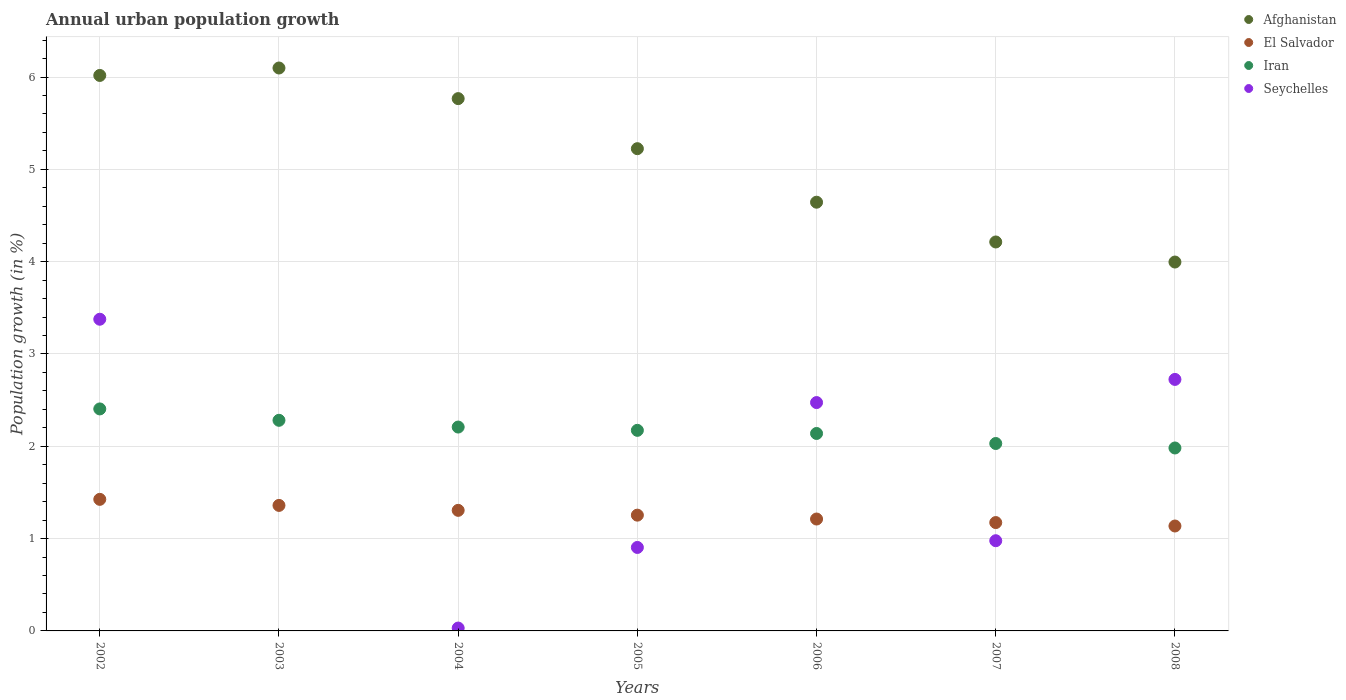Is the number of dotlines equal to the number of legend labels?
Give a very brief answer. No. What is the percentage of urban population growth in El Salvador in 2008?
Your response must be concise. 1.14. Across all years, what is the maximum percentage of urban population growth in Afghanistan?
Your response must be concise. 6.1. Across all years, what is the minimum percentage of urban population growth in Afghanistan?
Give a very brief answer. 4. In which year was the percentage of urban population growth in Iran maximum?
Offer a terse response. 2002. What is the total percentage of urban population growth in Afghanistan in the graph?
Provide a short and direct response. 35.96. What is the difference between the percentage of urban population growth in Iran in 2002 and that in 2006?
Offer a terse response. 0.27. What is the difference between the percentage of urban population growth in Seychelles in 2004 and the percentage of urban population growth in Iran in 2007?
Offer a terse response. -2. What is the average percentage of urban population growth in El Salvador per year?
Keep it short and to the point. 1.27. In the year 2008, what is the difference between the percentage of urban population growth in Afghanistan and percentage of urban population growth in Iran?
Your answer should be compact. 2.01. What is the ratio of the percentage of urban population growth in Iran in 2005 to that in 2006?
Provide a succinct answer. 1.02. Is the percentage of urban population growth in Seychelles in 2004 less than that in 2005?
Keep it short and to the point. Yes. Is the difference between the percentage of urban population growth in Afghanistan in 2006 and 2008 greater than the difference between the percentage of urban population growth in Iran in 2006 and 2008?
Keep it short and to the point. Yes. What is the difference between the highest and the second highest percentage of urban population growth in El Salvador?
Your answer should be very brief. 0.07. What is the difference between the highest and the lowest percentage of urban population growth in Afghanistan?
Keep it short and to the point. 2.1. In how many years, is the percentage of urban population growth in Afghanistan greater than the average percentage of urban population growth in Afghanistan taken over all years?
Give a very brief answer. 4. Is it the case that in every year, the sum of the percentage of urban population growth in El Salvador and percentage of urban population growth in Iran  is greater than the sum of percentage of urban population growth in Afghanistan and percentage of urban population growth in Seychelles?
Give a very brief answer. No. Is the percentage of urban population growth in Iran strictly greater than the percentage of urban population growth in Seychelles over the years?
Your response must be concise. No. Is the percentage of urban population growth in Iran strictly less than the percentage of urban population growth in Seychelles over the years?
Ensure brevity in your answer.  No. How many years are there in the graph?
Provide a succinct answer. 7. What is the difference between two consecutive major ticks on the Y-axis?
Keep it short and to the point. 1. Are the values on the major ticks of Y-axis written in scientific E-notation?
Offer a terse response. No. Does the graph contain any zero values?
Keep it short and to the point. Yes. Does the graph contain grids?
Provide a short and direct response. Yes. How are the legend labels stacked?
Your answer should be very brief. Vertical. What is the title of the graph?
Your response must be concise. Annual urban population growth. Does "Cote d'Ivoire" appear as one of the legend labels in the graph?
Keep it short and to the point. No. What is the label or title of the Y-axis?
Offer a terse response. Population growth (in %). What is the Population growth (in %) in Afghanistan in 2002?
Ensure brevity in your answer.  6.02. What is the Population growth (in %) in El Salvador in 2002?
Keep it short and to the point. 1.43. What is the Population growth (in %) in Iran in 2002?
Give a very brief answer. 2.4. What is the Population growth (in %) of Seychelles in 2002?
Your answer should be compact. 3.38. What is the Population growth (in %) in Afghanistan in 2003?
Provide a succinct answer. 6.1. What is the Population growth (in %) in El Salvador in 2003?
Give a very brief answer. 1.36. What is the Population growth (in %) in Iran in 2003?
Your answer should be compact. 2.28. What is the Population growth (in %) in Afghanistan in 2004?
Offer a terse response. 5.77. What is the Population growth (in %) of El Salvador in 2004?
Ensure brevity in your answer.  1.31. What is the Population growth (in %) of Iran in 2004?
Provide a short and direct response. 2.21. What is the Population growth (in %) of Seychelles in 2004?
Provide a succinct answer. 0.03. What is the Population growth (in %) in Afghanistan in 2005?
Offer a terse response. 5.22. What is the Population growth (in %) of El Salvador in 2005?
Provide a short and direct response. 1.25. What is the Population growth (in %) of Iran in 2005?
Keep it short and to the point. 2.17. What is the Population growth (in %) of Seychelles in 2005?
Provide a succinct answer. 0.9. What is the Population growth (in %) of Afghanistan in 2006?
Give a very brief answer. 4.64. What is the Population growth (in %) in El Salvador in 2006?
Provide a short and direct response. 1.21. What is the Population growth (in %) of Iran in 2006?
Keep it short and to the point. 2.14. What is the Population growth (in %) in Seychelles in 2006?
Ensure brevity in your answer.  2.47. What is the Population growth (in %) in Afghanistan in 2007?
Give a very brief answer. 4.21. What is the Population growth (in %) in El Salvador in 2007?
Offer a very short reply. 1.17. What is the Population growth (in %) of Iran in 2007?
Provide a succinct answer. 2.03. What is the Population growth (in %) in Seychelles in 2007?
Keep it short and to the point. 0.98. What is the Population growth (in %) of Afghanistan in 2008?
Make the answer very short. 4. What is the Population growth (in %) in El Salvador in 2008?
Your response must be concise. 1.14. What is the Population growth (in %) of Iran in 2008?
Your answer should be compact. 1.98. What is the Population growth (in %) in Seychelles in 2008?
Your answer should be compact. 2.72. Across all years, what is the maximum Population growth (in %) in Afghanistan?
Give a very brief answer. 6.1. Across all years, what is the maximum Population growth (in %) in El Salvador?
Your response must be concise. 1.43. Across all years, what is the maximum Population growth (in %) of Iran?
Offer a terse response. 2.4. Across all years, what is the maximum Population growth (in %) of Seychelles?
Make the answer very short. 3.38. Across all years, what is the minimum Population growth (in %) of Afghanistan?
Your answer should be very brief. 4. Across all years, what is the minimum Population growth (in %) in El Salvador?
Give a very brief answer. 1.14. Across all years, what is the minimum Population growth (in %) in Iran?
Keep it short and to the point. 1.98. Across all years, what is the minimum Population growth (in %) of Seychelles?
Your answer should be compact. 0. What is the total Population growth (in %) of Afghanistan in the graph?
Offer a very short reply. 35.96. What is the total Population growth (in %) of El Salvador in the graph?
Provide a succinct answer. 8.87. What is the total Population growth (in %) of Iran in the graph?
Provide a succinct answer. 15.22. What is the total Population growth (in %) of Seychelles in the graph?
Offer a terse response. 10.49. What is the difference between the Population growth (in %) in Afghanistan in 2002 and that in 2003?
Provide a short and direct response. -0.08. What is the difference between the Population growth (in %) in El Salvador in 2002 and that in 2003?
Your answer should be very brief. 0.07. What is the difference between the Population growth (in %) in Iran in 2002 and that in 2003?
Provide a short and direct response. 0.12. What is the difference between the Population growth (in %) of Afghanistan in 2002 and that in 2004?
Keep it short and to the point. 0.25. What is the difference between the Population growth (in %) in El Salvador in 2002 and that in 2004?
Make the answer very short. 0.12. What is the difference between the Population growth (in %) of Iran in 2002 and that in 2004?
Your answer should be very brief. 0.2. What is the difference between the Population growth (in %) in Seychelles in 2002 and that in 2004?
Offer a very short reply. 3.35. What is the difference between the Population growth (in %) in Afghanistan in 2002 and that in 2005?
Your response must be concise. 0.79. What is the difference between the Population growth (in %) in El Salvador in 2002 and that in 2005?
Make the answer very short. 0.17. What is the difference between the Population growth (in %) in Iran in 2002 and that in 2005?
Keep it short and to the point. 0.23. What is the difference between the Population growth (in %) in Seychelles in 2002 and that in 2005?
Provide a succinct answer. 2.47. What is the difference between the Population growth (in %) of Afghanistan in 2002 and that in 2006?
Offer a terse response. 1.37. What is the difference between the Population growth (in %) of El Salvador in 2002 and that in 2006?
Your answer should be very brief. 0.21. What is the difference between the Population growth (in %) of Iran in 2002 and that in 2006?
Keep it short and to the point. 0.27. What is the difference between the Population growth (in %) of Seychelles in 2002 and that in 2006?
Ensure brevity in your answer.  0.9. What is the difference between the Population growth (in %) of Afghanistan in 2002 and that in 2007?
Provide a short and direct response. 1.8. What is the difference between the Population growth (in %) in El Salvador in 2002 and that in 2007?
Offer a very short reply. 0.25. What is the difference between the Population growth (in %) in Iran in 2002 and that in 2007?
Keep it short and to the point. 0.37. What is the difference between the Population growth (in %) of Seychelles in 2002 and that in 2007?
Your answer should be very brief. 2.4. What is the difference between the Population growth (in %) in Afghanistan in 2002 and that in 2008?
Your response must be concise. 2.02. What is the difference between the Population growth (in %) of El Salvador in 2002 and that in 2008?
Give a very brief answer. 0.29. What is the difference between the Population growth (in %) in Iran in 2002 and that in 2008?
Make the answer very short. 0.42. What is the difference between the Population growth (in %) in Seychelles in 2002 and that in 2008?
Provide a succinct answer. 0.65. What is the difference between the Population growth (in %) of Afghanistan in 2003 and that in 2004?
Give a very brief answer. 0.33. What is the difference between the Population growth (in %) of El Salvador in 2003 and that in 2004?
Ensure brevity in your answer.  0.05. What is the difference between the Population growth (in %) in Iran in 2003 and that in 2004?
Your answer should be compact. 0.07. What is the difference between the Population growth (in %) of Afghanistan in 2003 and that in 2005?
Your answer should be compact. 0.87. What is the difference between the Population growth (in %) of El Salvador in 2003 and that in 2005?
Give a very brief answer. 0.11. What is the difference between the Population growth (in %) in Iran in 2003 and that in 2005?
Provide a succinct answer. 0.11. What is the difference between the Population growth (in %) in Afghanistan in 2003 and that in 2006?
Provide a short and direct response. 1.45. What is the difference between the Population growth (in %) in El Salvador in 2003 and that in 2006?
Your answer should be compact. 0.15. What is the difference between the Population growth (in %) of Iran in 2003 and that in 2006?
Your answer should be very brief. 0.14. What is the difference between the Population growth (in %) in Afghanistan in 2003 and that in 2007?
Make the answer very short. 1.88. What is the difference between the Population growth (in %) in El Salvador in 2003 and that in 2007?
Provide a succinct answer. 0.19. What is the difference between the Population growth (in %) of Iran in 2003 and that in 2007?
Give a very brief answer. 0.25. What is the difference between the Population growth (in %) in Afghanistan in 2003 and that in 2008?
Your response must be concise. 2.1. What is the difference between the Population growth (in %) of El Salvador in 2003 and that in 2008?
Give a very brief answer. 0.22. What is the difference between the Population growth (in %) in Iran in 2003 and that in 2008?
Ensure brevity in your answer.  0.3. What is the difference between the Population growth (in %) in Afghanistan in 2004 and that in 2005?
Keep it short and to the point. 0.54. What is the difference between the Population growth (in %) in El Salvador in 2004 and that in 2005?
Ensure brevity in your answer.  0.05. What is the difference between the Population growth (in %) of Iran in 2004 and that in 2005?
Ensure brevity in your answer.  0.04. What is the difference between the Population growth (in %) in Seychelles in 2004 and that in 2005?
Offer a very short reply. -0.87. What is the difference between the Population growth (in %) in Afghanistan in 2004 and that in 2006?
Keep it short and to the point. 1.12. What is the difference between the Population growth (in %) in El Salvador in 2004 and that in 2006?
Make the answer very short. 0.09. What is the difference between the Population growth (in %) of Iran in 2004 and that in 2006?
Your answer should be very brief. 0.07. What is the difference between the Population growth (in %) of Seychelles in 2004 and that in 2006?
Offer a terse response. -2.44. What is the difference between the Population growth (in %) in Afghanistan in 2004 and that in 2007?
Give a very brief answer. 1.55. What is the difference between the Population growth (in %) of El Salvador in 2004 and that in 2007?
Provide a short and direct response. 0.13. What is the difference between the Population growth (in %) in Iran in 2004 and that in 2007?
Ensure brevity in your answer.  0.18. What is the difference between the Population growth (in %) in Seychelles in 2004 and that in 2007?
Keep it short and to the point. -0.95. What is the difference between the Population growth (in %) of Afghanistan in 2004 and that in 2008?
Provide a short and direct response. 1.77. What is the difference between the Population growth (in %) of El Salvador in 2004 and that in 2008?
Ensure brevity in your answer.  0.17. What is the difference between the Population growth (in %) in Iran in 2004 and that in 2008?
Offer a very short reply. 0.23. What is the difference between the Population growth (in %) of Seychelles in 2004 and that in 2008?
Keep it short and to the point. -2.69. What is the difference between the Population growth (in %) of Afghanistan in 2005 and that in 2006?
Your answer should be compact. 0.58. What is the difference between the Population growth (in %) of El Salvador in 2005 and that in 2006?
Your answer should be compact. 0.04. What is the difference between the Population growth (in %) of Iran in 2005 and that in 2006?
Offer a very short reply. 0.03. What is the difference between the Population growth (in %) in Seychelles in 2005 and that in 2006?
Offer a very short reply. -1.57. What is the difference between the Population growth (in %) in Afghanistan in 2005 and that in 2007?
Offer a very short reply. 1.01. What is the difference between the Population growth (in %) in El Salvador in 2005 and that in 2007?
Make the answer very short. 0.08. What is the difference between the Population growth (in %) in Iran in 2005 and that in 2007?
Offer a terse response. 0.14. What is the difference between the Population growth (in %) in Seychelles in 2005 and that in 2007?
Offer a terse response. -0.07. What is the difference between the Population growth (in %) of Afghanistan in 2005 and that in 2008?
Your response must be concise. 1.23. What is the difference between the Population growth (in %) in El Salvador in 2005 and that in 2008?
Provide a short and direct response. 0.12. What is the difference between the Population growth (in %) in Iran in 2005 and that in 2008?
Your response must be concise. 0.19. What is the difference between the Population growth (in %) in Seychelles in 2005 and that in 2008?
Ensure brevity in your answer.  -1.82. What is the difference between the Population growth (in %) in Afghanistan in 2006 and that in 2007?
Provide a succinct answer. 0.43. What is the difference between the Population growth (in %) in El Salvador in 2006 and that in 2007?
Offer a terse response. 0.04. What is the difference between the Population growth (in %) of Iran in 2006 and that in 2007?
Provide a short and direct response. 0.11. What is the difference between the Population growth (in %) in Seychelles in 2006 and that in 2007?
Offer a terse response. 1.5. What is the difference between the Population growth (in %) in Afghanistan in 2006 and that in 2008?
Provide a succinct answer. 0.65. What is the difference between the Population growth (in %) in El Salvador in 2006 and that in 2008?
Offer a very short reply. 0.08. What is the difference between the Population growth (in %) in Iran in 2006 and that in 2008?
Keep it short and to the point. 0.16. What is the difference between the Population growth (in %) in Seychelles in 2006 and that in 2008?
Keep it short and to the point. -0.25. What is the difference between the Population growth (in %) in Afghanistan in 2007 and that in 2008?
Your answer should be compact. 0.22. What is the difference between the Population growth (in %) of El Salvador in 2007 and that in 2008?
Your response must be concise. 0.04. What is the difference between the Population growth (in %) of Iran in 2007 and that in 2008?
Offer a very short reply. 0.05. What is the difference between the Population growth (in %) of Seychelles in 2007 and that in 2008?
Keep it short and to the point. -1.75. What is the difference between the Population growth (in %) in Afghanistan in 2002 and the Population growth (in %) in El Salvador in 2003?
Your answer should be compact. 4.66. What is the difference between the Population growth (in %) in Afghanistan in 2002 and the Population growth (in %) in Iran in 2003?
Offer a terse response. 3.74. What is the difference between the Population growth (in %) in El Salvador in 2002 and the Population growth (in %) in Iran in 2003?
Your response must be concise. -0.86. What is the difference between the Population growth (in %) of Afghanistan in 2002 and the Population growth (in %) of El Salvador in 2004?
Give a very brief answer. 4.71. What is the difference between the Population growth (in %) in Afghanistan in 2002 and the Population growth (in %) in Iran in 2004?
Offer a terse response. 3.81. What is the difference between the Population growth (in %) in Afghanistan in 2002 and the Population growth (in %) in Seychelles in 2004?
Your answer should be very brief. 5.99. What is the difference between the Population growth (in %) in El Salvador in 2002 and the Population growth (in %) in Iran in 2004?
Make the answer very short. -0.78. What is the difference between the Population growth (in %) of El Salvador in 2002 and the Population growth (in %) of Seychelles in 2004?
Keep it short and to the point. 1.39. What is the difference between the Population growth (in %) in Iran in 2002 and the Population growth (in %) in Seychelles in 2004?
Give a very brief answer. 2.37. What is the difference between the Population growth (in %) in Afghanistan in 2002 and the Population growth (in %) in El Salvador in 2005?
Ensure brevity in your answer.  4.76. What is the difference between the Population growth (in %) of Afghanistan in 2002 and the Population growth (in %) of Iran in 2005?
Make the answer very short. 3.84. What is the difference between the Population growth (in %) in Afghanistan in 2002 and the Population growth (in %) in Seychelles in 2005?
Provide a succinct answer. 5.11. What is the difference between the Population growth (in %) in El Salvador in 2002 and the Population growth (in %) in Iran in 2005?
Your answer should be compact. -0.75. What is the difference between the Population growth (in %) in El Salvador in 2002 and the Population growth (in %) in Seychelles in 2005?
Your answer should be compact. 0.52. What is the difference between the Population growth (in %) in Iran in 2002 and the Population growth (in %) in Seychelles in 2005?
Provide a short and direct response. 1.5. What is the difference between the Population growth (in %) in Afghanistan in 2002 and the Population growth (in %) in El Salvador in 2006?
Your response must be concise. 4.8. What is the difference between the Population growth (in %) in Afghanistan in 2002 and the Population growth (in %) in Iran in 2006?
Make the answer very short. 3.88. What is the difference between the Population growth (in %) of Afghanistan in 2002 and the Population growth (in %) of Seychelles in 2006?
Provide a succinct answer. 3.54. What is the difference between the Population growth (in %) of El Salvador in 2002 and the Population growth (in %) of Iran in 2006?
Provide a succinct answer. -0.71. What is the difference between the Population growth (in %) of El Salvador in 2002 and the Population growth (in %) of Seychelles in 2006?
Offer a very short reply. -1.05. What is the difference between the Population growth (in %) in Iran in 2002 and the Population growth (in %) in Seychelles in 2006?
Ensure brevity in your answer.  -0.07. What is the difference between the Population growth (in %) in Afghanistan in 2002 and the Population growth (in %) in El Salvador in 2007?
Make the answer very short. 4.84. What is the difference between the Population growth (in %) of Afghanistan in 2002 and the Population growth (in %) of Iran in 2007?
Offer a terse response. 3.99. What is the difference between the Population growth (in %) of Afghanistan in 2002 and the Population growth (in %) of Seychelles in 2007?
Offer a very short reply. 5.04. What is the difference between the Population growth (in %) in El Salvador in 2002 and the Population growth (in %) in Iran in 2007?
Provide a short and direct response. -0.6. What is the difference between the Population growth (in %) in El Salvador in 2002 and the Population growth (in %) in Seychelles in 2007?
Provide a succinct answer. 0.45. What is the difference between the Population growth (in %) of Iran in 2002 and the Population growth (in %) of Seychelles in 2007?
Provide a short and direct response. 1.43. What is the difference between the Population growth (in %) in Afghanistan in 2002 and the Population growth (in %) in El Salvador in 2008?
Keep it short and to the point. 4.88. What is the difference between the Population growth (in %) in Afghanistan in 2002 and the Population growth (in %) in Iran in 2008?
Provide a succinct answer. 4.04. What is the difference between the Population growth (in %) of Afghanistan in 2002 and the Population growth (in %) of Seychelles in 2008?
Provide a short and direct response. 3.29. What is the difference between the Population growth (in %) of El Salvador in 2002 and the Population growth (in %) of Iran in 2008?
Offer a very short reply. -0.56. What is the difference between the Population growth (in %) in El Salvador in 2002 and the Population growth (in %) in Seychelles in 2008?
Make the answer very short. -1.3. What is the difference between the Population growth (in %) of Iran in 2002 and the Population growth (in %) of Seychelles in 2008?
Make the answer very short. -0.32. What is the difference between the Population growth (in %) of Afghanistan in 2003 and the Population growth (in %) of El Salvador in 2004?
Offer a very short reply. 4.79. What is the difference between the Population growth (in %) in Afghanistan in 2003 and the Population growth (in %) in Iran in 2004?
Make the answer very short. 3.89. What is the difference between the Population growth (in %) in Afghanistan in 2003 and the Population growth (in %) in Seychelles in 2004?
Keep it short and to the point. 6.07. What is the difference between the Population growth (in %) of El Salvador in 2003 and the Population growth (in %) of Iran in 2004?
Offer a terse response. -0.85. What is the difference between the Population growth (in %) of El Salvador in 2003 and the Population growth (in %) of Seychelles in 2004?
Provide a short and direct response. 1.33. What is the difference between the Population growth (in %) in Iran in 2003 and the Population growth (in %) in Seychelles in 2004?
Your answer should be very brief. 2.25. What is the difference between the Population growth (in %) in Afghanistan in 2003 and the Population growth (in %) in El Salvador in 2005?
Offer a very short reply. 4.84. What is the difference between the Population growth (in %) in Afghanistan in 2003 and the Population growth (in %) in Iran in 2005?
Offer a very short reply. 3.92. What is the difference between the Population growth (in %) of Afghanistan in 2003 and the Population growth (in %) of Seychelles in 2005?
Your answer should be compact. 5.19. What is the difference between the Population growth (in %) in El Salvador in 2003 and the Population growth (in %) in Iran in 2005?
Your answer should be very brief. -0.81. What is the difference between the Population growth (in %) of El Salvador in 2003 and the Population growth (in %) of Seychelles in 2005?
Give a very brief answer. 0.46. What is the difference between the Population growth (in %) in Iran in 2003 and the Population growth (in %) in Seychelles in 2005?
Make the answer very short. 1.38. What is the difference between the Population growth (in %) in Afghanistan in 2003 and the Population growth (in %) in El Salvador in 2006?
Provide a succinct answer. 4.89. What is the difference between the Population growth (in %) in Afghanistan in 2003 and the Population growth (in %) in Iran in 2006?
Provide a short and direct response. 3.96. What is the difference between the Population growth (in %) in Afghanistan in 2003 and the Population growth (in %) in Seychelles in 2006?
Your answer should be compact. 3.62. What is the difference between the Population growth (in %) in El Salvador in 2003 and the Population growth (in %) in Iran in 2006?
Your answer should be very brief. -0.78. What is the difference between the Population growth (in %) in El Salvador in 2003 and the Population growth (in %) in Seychelles in 2006?
Offer a terse response. -1.11. What is the difference between the Population growth (in %) of Iran in 2003 and the Population growth (in %) of Seychelles in 2006?
Offer a very short reply. -0.19. What is the difference between the Population growth (in %) in Afghanistan in 2003 and the Population growth (in %) in El Salvador in 2007?
Offer a terse response. 4.92. What is the difference between the Population growth (in %) in Afghanistan in 2003 and the Population growth (in %) in Iran in 2007?
Make the answer very short. 4.07. What is the difference between the Population growth (in %) in Afghanistan in 2003 and the Population growth (in %) in Seychelles in 2007?
Offer a terse response. 5.12. What is the difference between the Population growth (in %) in El Salvador in 2003 and the Population growth (in %) in Iran in 2007?
Provide a short and direct response. -0.67. What is the difference between the Population growth (in %) of El Salvador in 2003 and the Population growth (in %) of Seychelles in 2007?
Keep it short and to the point. 0.38. What is the difference between the Population growth (in %) of Iran in 2003 and the Population growth (in %) of Seychelles in 2007?
Keep it short and to the point. 1.3. What is the difference between the Population growth (in %) in Afghanistan in 2003 and the Population growth (in %) in El Salvador in 2008?
Ensure brevity in your answer.  4.96. What is the difference between the Population growth (in %) of Afghanistan in 2003 and the Population growth (in %) of Iran in 2008?
Offer a terse response. 4.12. What is the difference between the Population growth (in %) of Afghanistan in 2003 and the Population growth (in %) of Seychelles in 2008?
Your answer should be very brief. 3.37. What is the difference between the Population growth (in %) of El Salvador in 2003 and the Population growth (in %) of Iran in 2008?
Your answer should be compact. -0.62. What is the difference between the Population growth (in %) of El Salvador in 2003 and the Population growth (in %) of Seychelles in 2008?
Your response must be concise. -1.36. What is the difference between the Population growth (in %) in Iran in 2003 and the Population growth (in %) in Seychelles in 2008?
Ensure brevity in your answer.  -0.44. What is the difference between the Population growth (in %) of Afghanistan in 2004 and the Population growth (in %) of El Salvador in 2005?
Ensure brevity in your answer.  4.51. What is the difference between the Population growth (in %) in Afghanistan in 2004 and the Population growth (in %) in Iran in 2005?
Your response must be concise. 3.59. What is the difference between the Population growth (in %) of Afghanistan in 2004 and the Population growth (in %) of Seychelles in 2005?
Provide a succinct answer. 4.86. What is the difference between the Population growth (in %) of El Salvador in 2004 and the Population growth (in %) of Iran in 2005?
Keep it short and to the point. -0.87. What is the difference between the Population growth (in %) of El Salvador in 2004 and the Population growth (in %) of Seychelles in 2005?
Make the answer very short. 0.4. What is the difference between the Population growth (in %) in Iran in 2004 and the Population growth (in %) in Seychelles in 2005?
Your answer should be very brief. 1.3. What is the difference between the Population growth (in %) of Afghanistan in 2004 and the Population growth (in %) of El Salvador in 2006?
Provide a succinct answer. 4.55. What is the difference between the Population growth (in %) of Afghanistan in 2004 and the Population growth (in %) of Iran in 2006?
Provide a succinct answer. 3.63. What is the difference between the Population growth (in %) of Afghanistan in 2004 and the Population growth (in %) of Seychelles in 2006?
Provide a short and direct response. 3.29. What is the difference between the Population growth (in %) of El Salvador in 2004 and the Population growth (in %) of Iran in 2006?
Your answer should be very brief. -0.83. What is the difference between the Population growth (in %) of El Salvador in 2004 and the Population growth (in %) of Seychelles in 2006?
Your response must be concise. -1.17. What is the difference between the Population growth (in %) in Iran in 2004 and the Population growth (in %) in Seychelles in 2006?
Provide a succinct answer. -0.27. What is the difference between the Population growth (in %) of Afghanistan in 2004 and the Population growth (in %) of El Salvador in 2007?
Your answer should be compact. 4.59. What is the difference between the Population growth (in %) of Afghanistan in 2004 and the Population growth (in %) of Iran in 2007?
Your answer should be compact. 3.74. What is the difference between the Population growth (in %) of Afghanistan in 2004 and the Population growth (in %) of Seychelles in 2007?
Give a very brief answer. 4.79. What is the difference between the Population growth (in %) of El Salvador in 2004 and the Population growth (in %) of Iran in 2007?
Your answer should be compact. -0.72. What is the difference between the Population growth (in %) of El Salvador in 2004 and the Population growth (in %) of Seychelles in 2007?
Offer a very short reply. 0.33. What is the difference between the Population growth (in %) of Iran in 2004 and the Population growth (in %) of Seychelles in 2007?
Ensure brevity in your answer.  1.23. What is the difference between the Population growth (in %) in Afghanistan in 2004 and the Population growth (in %) in El Salvador in 2008?
Provide a succinct answer. 4.63. What is the difference between the Population growth (in %) of Afghanistan in 2004 and the Population growth (in %) of Iran in 2008?
Offer a very short reply. 3.78. What is the difference between the Population growth (in %) of Afghanistan in 2004 and the Population growth (in %) of Seychelles in 2008?
Keep it short and to the point. 3.04. What is the difference between the Population growth (in %) of El Salvador in 2004 and the Population growth (in %) of Iran in 2008?
Give a very brief answer. -0.68. What is the difference between the Population growth (in %) in El Salvador in 2004 and the Population growth (in %) in Seychelles in 2008?
Provide a short and direct response. -1.42. What is the difference between the Population growth (in %) of Iran in 2004 and the Population growth (in %) of Seychelles in 2008?
Ensure brevity in your answer.  -0.52. What is the difference between the Population growth (in %) in Afghanistan in 2005 and the Population growth (in %) in El Salvador in 2006?
Your answer should be very brief. 4.01. What is the difference between the Population growth (in %) in Afghanistan in 2005 and the Population growth (in %) in Iran in 2006?
Give a very brief answer. 3.08. What is the difference between the Population growth (in %) of Afghanistan in 2005 and the Population growth (in %) of Seychelles in 2006?
Provide a short and direct response. 2.75. What is the difference between the Population growth (in %) in El Salvador in 2005 and the Population growth (in %) in Iran in 2006?
Provide a succinct answer. -0.88. What is the difference between the Population growth (in %) of El Salvador in 2005 and the Population growth (in %) of Seychelles in 2006?
Your answer should be compact. -1.22. What is the difference between the Population growth (in %) in Iran in 2005 and the Population growth (in %) in Seychelles in 2006?
Provide a short and direct response. -0.3. What is the difference between the Population growth (in %) in Afghanistan in 2005 and the Population growth (in %) in El Salvador in 2007?
Your answer should be compact. 4.05. What is the difference between the Population growth (in %) of Afghanistan in 2005 and the Population growth (in %) of Iran in 2007?
Keep it short and to the point. 3.19. What is the difference between the Population growth (in %) of Afghanistan in 2005 and the Population growth (in %) of Seychelles in 2007?
Keep it short and to the point. 4.25. What is the difference between the Population growth (in %) of El Salvador in 2005 and the Population growth (in %) of Iran in 2007?
Ensure brevity in your answer.  -0.78. What is the difference between the Population growth (in %) of El Salvador in 2005 and the Population growth (in %) of Seychelles in 2007?
Provide a succinct answer. 0.28. What is the difference between the Population growth (in %) of Iran in 2005 and the Population growth (in %) of Seychelles in 2007?
Offer a very short reply. 1.2. What is the difference between the Population growth (in %) of Afghanistan in 2005 and the Population growth (in %) of El Salvador in 2008?
Your answer should be compact. 4.09. What is the difference between the Population growth (in %) in Afghanistan in 2005 and the Population growth (in %) in Iran in 2008?
Provide a succinct answer. 3.24. What is the difference between the Population growth (in %) in Afghanistan in 2005 and the Population growth (in %) in Seychelles in 2008?
Give a very brief answer. 2.5. What is the difference between the Population growth (in %) in El Salvador in 2005 and the Population growth (in %) in Iran in 2008?
Your response must be concise. -0.73. What is the difference between the Population growth (in %) in El Salvador in 2005 and the Population growth (in %) in Seychelles in 2008?
Ensure brevity in your answer.  -1.47. What is the difference between the Population growth (in %) in Iran in 2005 and the Population growth (in %) in Seychelles in 2008?
Provide a short and direct response. -0.55. What is the difference between the Population growth (in %) of Afghanistan in 2006 and the Population growth (in %) of El Salvador in 2007?
Make the answer very short. 3.47. What is the difference between the Population growth (in %) in Afghanistan in 2006 and the Population growth (in %) in Iran in 2007?
Ensure brevity in your answer.  2.61. What is the difference between the Population growth (in %) in Afghanistan in 2006 and the Population growth (in %) in Seychelles in 2007?
Offer a terse response. 3.67. What is the difference between the Population growth (in %) of El Salvador in 2006 and the Population growth (in %) of Iran in 2007?
Make the answer very short. -0.82. What is the difference between the Population growth (in %) of El Salvador in 2006 and the Population growth (in %) of Seychelles in 2007?
Provide a short and direct response. 0.23. What is the difference between the Population growth (in %) of Iran in 2006 and the Population growth (in %) of Seychelles in 2007?
Give a very brief answer. 1.16. What is the difference between the Population growth (in %) of Afghanistan in 2006 and the Population growth (in %) of El Salvador in 2008?
Keep it short and to the point. 3.51. What is the difference between the Population growth (in %) in Afghanistan in 2006 and the Population growth (in %) in Iran in 2008?
Give a very brief answer. 2.66. What is the difference between the Population growth (in %) in Afghanistan in 2006 and the Population growth (in %) in Seychelles in 2008?
Give a very brief answer. 1.92. What is the difference between the Population growth (in %) in El Salvador in 2006 and the Population growth (in %) in Iran in 2008?
Offer a very short reply. -0.77. What is the difference between the Population growth (in %) in El Salvador in 2006 and the Population growth (in %) in Seychelles in 2008?
Provide a succinct answer. -1.51. What is the difference between the Population growth (in %) in Iran in 2006 and the Population growth (in %) in Seychelles in 2008?
Offer a terse response. -0.59. What is the difference between the Population growth (in %) in Afghanistan in 2007 and the Population growth (in %) in El Salvador in 2008?
Your response must be concise. 3.08. What is the difference between the Population growth (in %) in Afghanistan in 2007 and the Population growth (in %) in Iran in 2008?
Make the answer very short. 2.23. What is the difference between the Population growth (in %) in Afghanistan in 2007 and the Population growth (in %) in Seychelles in 2008?
Offer a terse response. 1.49. What is the difference between the Population growth (in %) of El Salvador in 2007 and the Population growth (in %) of Iran in 2008?
Keep it short and to the point. -0.81. What is the difference between the Population growth (in %) of El Salvador in 2007 and the Population growth (in %) of Seychelles in 2008?
Offer a very short reply. -1.55. What is the difference between the Population growth (in %) of Iran in 2007 and the Population growth (in %) of Seychelles in 2008?
Offer a very short reply. -0.69. What is the average Population growth (in %) in Afghanistan per year?
Ensure brevity in your answer.  5.14. What is the average Population growth (in %) of El Salvador per year?
Provide a short and direct response. 1.27. What is the average Population growth (in %) in Iran per year?
Keep it short and to the point. 2.17. What is the average Population growth (in %) in Seychelles per year?
Offer a very short reply. 1.5. In the year 2002, what is the difference between the Population growth (in %) in Afghanistan and Population growth (in %) in El Salvador?
Your answer should be compact. 4.59. In the year 2002, what is the difference between the Population growth (in %) in Afghanistan and Population growth (in %) in Iran?
Make the answer very short. 3.61. In the year 2002, what is the difference between the Population growth (in %) in Afghanistan and Population growth (in %) in Seychelles?
Your answer should be very brief. 2.64. In the year 2002, what is the difference between the Population growth (in %) of El Salvador and Population growth (in %) of Iran?
Provide a succinct answer. -0.98. In the year 2002, what is the difference between the Population growth (in %) in El Salvador and Population growth (in %) in Seychelles?
Keep it short and to the point. -1.95. In the year 2002, what is the difference between the Population growth (in %) of Iran and Population growth (in %) of Seychelles?
Keep it short and to the point. -0.97. In the year 2003, what is the difference between the Population growth (in %) in Afghanistan and Population growth (in %) in El Salvador?
Make the answer very short. 4.74. In the year 2003, what is the difference between the Population growth (in %) in Afghanistan and Population growth (in %) in Iran?
Offer a very short reply. 3.82. In the year 2003, what is the difference between the Population growth (in %) of El Salvador and Population growth (in %) of Iran?
Make the answer very short. -0.92. In the year 2004, what is the difference between the Population growth (in %) of Afghanistan and Population growth (in %) of El Salvador?
Your answer should be very brief. 4.46. In the year 2004, what is the difference between the Population growth (in %) in Afghanistan and Population growth (in %) in Iran?
Ensure brevity in your answer.  3.56. In the year 2004, what is the difference between the Population growth (in %) of Afghanistan and Population growth (in %) of Seychelles?
Ensure brevity in your answer.  5.74. In the year 2004, what is the difference between the Population growth (in %) in El Salvador and Population growth (in %) in Iran?
Make the answer very short. -0.9. In the year 2004, what is the difference between the Population growth (in %) in El Salvador and Population growth (in %) in Seychelles?
Make the answer very short. 1.28. In the year 2004, what is the difference between the Population growth (in %) of Iran and Population growth (in %) of Seychelles?
Offer a very short reply. 2.18. In the year 2005, what is the difference between the Population growth (in %) in Afghanistan and Population growth (in %) in El Salvador?
Keep it short and to the point. 3.97. In the year 2005, what is the difference between the Population growth (in %) in Afghanistan and Population growth (in %) in Iran?
Your response must be concise. 3.05. In the year 2005, what is the difference between the Population growth (in %) of Afghanistan and Population growth (in %) of Seychelles?
Ensure brevity in your answer.  4.32. In the year 2005, what is the difference between the Population growth (in %) of El Salvador and Population growth (in %) of Iran?
Keep it short and to the point. -0.92. In the year 2005, what is the difference between the Population growth (in %) of El Salvador and Population growth (in %) of Seychelles?
Provide a succinct answer. 0.35. In the year 2005, what is the difference between the Population growth (in %) of Iran and Population growth (in %) of Seychelles?
Give a very brief answer. 1.27. In the year 2006, what is the difference between the Population growth (in %) in Afghanistan and Population growth (in %) in El Salvador?
Provide a short and direct response. 3.43. In the year 2006, what is the difference between the Population growth (in %) of Afghanistan and Population growth (in %) of Iran?
Keep it short and to the point. 2.51. In the year 2006, what is the difference between the Population growth (in %) of Afghanistan and Population growth (in %) of Seychelles?
Your response must be concise. 2.17. In the year 2006, what is the difference between the Population growth (in %) in El Salvador and Population growth (in %) in Iran?
Offer a very short reply. -0.93. In the year 2006, what is the difference between the Population growth (in %) of El Salvador and Population growth (in %) of Seychelles?
Provide a short and direct response. -1.26. In the year 2006, what is the difference between the Population growth (in %) in Iran and Population growth (in %) in Seychelles?
Your response must be concise. -0.33. In the year 2007, what is the difference between the Population growth (in %) of Afghanistan and Population growth (in %) of El Salvador?
Offer a very short reply. 3.04. In the year 2007, what is the difference between the Population growth (in %) of Afghanistan and Population growth (in %) of Iran?
Keep it short and to the point. 2.18. In the year 2007, what is the difference between the Population growth (in %) of Afghanistan and Population growth (in %) of Seychelles?
Offer a terse response. 3.24. In the year 2007, what is the difference between the Population growth (in %) of El Salvador and Population growth (in %) of Iran?
Your answer should be very brief. -0.86. In the year 2007, what is the difference between the Population growth (in %) in El Salvador and Population growth (in %) in Seychelles?
Keep it short and to the point. 0.2. In the year 2007, what is the difference between the Population growth (in %) in Iran and Population growth (in %) in Seychelles?
Offer a very short reply. 1.05. In the year 2008, what is the difference between the Population growth (in %) of Afghanistan and Population growth (in %) of El Salvador?
Your answer should be very brief. 2.86. In the year 2008, what is the difference between the Population growth (in %) of Afghanistan and Population growth (in %) of Iran?
Your response must be concise. 2.01. In the year 2008, what is the difference between the Population growth (in %) in Afghanistan and Population growth (in %) in Seychelles?
Your response must be concise. 1.27. In the year 2008, what is the difference between the Population growth (in %) of El Salvador and Population growth (in %) of Iran?
Your answer should be very brief. -0.85. In the year 2008, what is the difference between the Population growth (in %) of El Salvador and Population growth (in %) of Seychelles?
Provide a succinct answer. -1.59. In the year 2008, what is the difference between the Population growth (in %) of Iran and Population growth (in %) of Seychelles?
Your answer should be very brief. -0.74. What is the ratio of the Population growth (in %) of Afghanistan in 2002 to that in 2003?
Keep it short and to the point. 0.99. What is the ratio of the Population growth (in %) in El Salvador in 2002 to that in 2003?
Keep it short and to the point. 1.05. What is the ratio of the Population growth (in %) of Iran in 2002 to that in 2003?
Provide a succinct answer. 1.05. What is the ratio of the Population growth (in %) in Afghanistan in 2002 to that in 2004?
Keep it short and to the point. 1.04. What is the ratio of the Population growth (in %) of El Salvador in 2002 to that in 2004?
Offer a very short reply. 1.09. What is the ratio of the Population growth (in %) in Iran in 2002 to that in 2004?
Give a very brief answer. 1.09. What is the ratio of the Population growth (in %) in Seychelles in 2002 to that in 2004?
Ensure brevity in your answer.  108.92. What is the ratio of the Population growth (in %) of Afghanistan in 2002 to that in 2005?
Ensure brevity in your answer.  1.15. What is the ratio of the Population growth (in %) of El Salvador in 2002 to that in 2005?
Your answer should be compact. 1.14. What is the ratio of the Population growth (in %) of Iran in 2002 to that in 2005?
Provide a short and direct response. 1.11. What is the ratio of the Population growth (in %) of Seychelles in 2002 to that in 2005?
Your response must be concise. 3.73. What is the ratio of the Population growth (in %) of Afghanistan in 2002 to that in 2006?
Your answer should be very brief. 1.3. What is the ratio of the Population growth (in %) of El Salvador in 2002 to that in 2006?
Provide a succinct answer. 1.18. What is the ratio of the Population growth (in %) of Iran in 2002 to that in 2006?
Make the answer very short. 1.12. What is the ratio of the Population growth (in %) in Seychelles in 2002 to that in 2006?
Give a very brief answer. 1.36. What is the ratio of the Population growth (in %) in Afghanistan in 2002 to that in 2007?
Make the answer very short. 1.43. What is the ratio of the Population growth (in %) of El Salvador in 2002 to that in 2007?
Your answer should be compact. 1.21. What is the ratio of the Population growth (in %) in Iran in 2002 to that in 2007?
Give a very brief answer. 1.18. What is the ratio of the Population growth (in %) of Seychelles in 2002 to that in 2007?
Make the answer very short. 3.46. What is the ratio of the Population growth (in %) in Afghanistan in 2002 to that in 2008?
Give a very brief answer. 1.51. What is the ratio of the Population growth (in %) in El Salvador in 2002 to that in 2008?
Offer a very short reply. 1.25. What is the ratio of the Population growth (in %) of Iran in 2002 to that in 2008?
Keep it short and to the point. 1.21. What is the ratio of the Population growth (in %) of Seychelles in 2002 to that in 2008?
Offer a very short reply. 1.24. What is the ratio of the Population growth (in %) of Afghanistan in 2003 to that in 2004?
Your answer should be very brief. 1.06. What is the ratio of the Population growth (in %) of El Salvador in 2003 to that in 2004?
Your response must be concise. 1.04. What is the ratio of the Population growth (in %) in Iran in 2003 to that in 2004?
Provide a succinct answer. 1.03. What is the ratio of the Population growth (in %) of Afghanistan in 2003 to that in 2005?
Your answer should be compact. 1.17. What is the ratio of the Population growth (in %) of El Salvador in 2003 to that in 2005?
Your response must be concise. 1.08. What is the ratio of the Population growth (in %) in Afghanistan in 2003 to that in 2006?
Provide a short and direct response. 1.31. What is the ratio of the Population growth (in %) in El Salvador in 2003 to that in 2006?
Offer a very short reply. 1.12. What is the ratio of the Population growth (in %) in Iran in 2003 to that in 2006?
Your answer should be very brief. 1.07. What is the ratio of the Population growth (in %) in Afghanistan in 2003 to that in 2007?
Your response must be concise. 1.45. What is the ratio of the Population growth (in %) in El Salvador in 2003 to that in 2007?
Your answer should be compact. 1.16. What is the ratio of the Population growth (in %) of Iran in 2003 to that in 2007?
Keep it short and to the point. 1.12. What is the ratio of the Population growth (in %) of Afghanistan in 2003 to that in 2008?
Your answer should be very brief. 1.53. What is the ratio of the Population growth (in %) of El Salvador in 2003 to that in 2008?
Make the answer very short. 1.2. What is the ratio of the Population growth (in %) in Iran in 2003 to that in 2008?
Keep it short and to the point. 1.15. What is the ratio of the Population growth (in %) in Afghanistan in 2004 to that in 2005?
Offer a terse response. 1.1. What is the ratio of the Population growth (in %) in El Salvador in 2004 to that in 2005?
Ensure brevity in your answer.  1.04. What is the ratio of the Population growth (in %) in Iran in 2004 to that in 2005?
Make the answer very short. 1.02. What is the ratio of the Population growth (in %) of Seychelles in 2004 to that in 2005?
Your answer should be compact. 0.03. What is the ratio of the Population growth (in %) in Afghanistan in 2004 to that in 2006?
Make the answer very short. 1.24. What is the ratio of the Population growth (in %) of El Salvador in 2004 to that in 2006?
Your answer should be compact. 1.08. What is the ratio of the Population growth (in %) in Iran in 2004 to that in 2006?
Your answer should be compact. 1.03. What is the ratio of the Population growth (in %) in Seychelles in 2004 to that in 2006?
Your response must be concise. 0.01. What is the ratio of the Population growth (in %) in Afghanistan in 2004 to that in 2007?
Offer a terse response. 1.37. What is the ratio of the Population growth (in %) of El Salvador in 2004 to that in 2007?
Your answer should be very brief. 1.11. What is the ratio of the Population growth (in %) of Iran in 2004 to that in 2007?
Provide a short and direct response. 1.09. What is the ratio of the Population growth (in %) in Seychelles in 2004 to that in 2007?
Provide a short and direct response. 0.03. What is the ratio of the Population growth (in %) in Afghanistan in 2004 to that in 2008?
Your response must be concise. 1.44. What is the ratio of the Population growth (in %) in El Salvador in 2004 to that in 2008?
Your answer should be compact. 1.15. What is the ratio of the Population growth (in %) in Iran in 2004 to that in 2008?
Make the answer very short. 1.11. What is the ratio of the Population growth (in %) of Seychelles in 2004 to that in 2008?
Keep it short and to the point. 0.01. What is the ratio of the Population growth (in %) of Afghanistan in 2005 to that in 2006?
Provide a succinct answer. 1.12. What is the ratio of the Population growth (in %) of El Salvador in 2005 to that in 2006?
Ensure brevity in your answer.  1.03. What is the ratio of the Population growth (in %) of Iran in 2005 to that in 2006?
Your answer should be compact. 1.02. What is the ratio of the Population growth (in %) of Seychelles in 2005 to that in 2006?
Your response must be concise. 0.37. What is the ratio of the Population growth (in %) in Afghanistan in 2005 to that in 2007?
Provide a succinct answer. 1.24. What is the ratio of the Population growth (in %) in El Salvador in 2005 to that in 2007?
Ensure brevity in your answer.  1.07. What is the ratio of the Population growth (in %) of Iran in 2005 to that in 2007?
Provide a short and direct response. 1.07. What is the ratio of the Population growth (in %) in Seychelles in 2005 to that in 2007?
Your answer should be compact. 0.93. What is the ratio of the Population growth (in %) in Afghanistan in 2005 to that in 2008?
Offer a very short reply. 1.31. What is the ratio of the Population growth (in %) of El Salvador in 2005 to that in 2008?
Ensure brevity in your answer.  1.1. What is the ratio of the Population growth (in %) in Iran in 2005 to that in 2008?
Provide a succinct answer. 1.1. What is the ratio of the Population growth (in %) of Seychelles in 2005 to that in 2008?
Your answer should be very brief. 0.33. What is the ratio of the Population growth (in %) of Afghanistan in 2006 to that in 2007?
Offer a very short reply. 1.1. What is the ratio of the Population growth (in %) of El Salvador in 2006 to that in 2007?
Provide a succinct answer. 1.03. What is the ratio of the Population growth (in %) of Iran in 2006 to that in 2007?
Make the answer very short. 1.05. What is the ratio of the Population growth (in %) in Seychelles in 2006 to that in 2007?
Your answer should be compact. 2.53. What is the ratio of the Population growth (in %) of Afghanistan in 2006 to that in 2008?
Provide a short and direct response. 1.16. What is the ratio of the Population growth (in %) in El Salvador in 2006 to that in 2008?
Keep it short and to the point. 1.07. What is the ratio of the Population growth (in %) in Iran in 2006 to that in 2008?
Your answer should be compact. 1.08. What is the ratio of the Population growth (in %) of Seychelles in 2006 to that in 2008?
Your answer should be very brief. 0.91. What is the ratio of the Population growth (in %) of Afghanistan in 2007 to that in 2008?
Your response must be concise. 1.05. What is the ratio of the Population growth (in %) of El Salvador in 2007 to that in 2008?
Offer a very short reply. 1.03. What is the ratio of the Population growth (in %) in Iran in 2007 to that in 2008?
Make the answer very short. 1.02. What is the ratio of the Population growth (in %) in Seychelles in 2007 to that in 2008?
Your response must be concise. 0.36. What is the difference between the highest and the second highest Population growth (in %) of Afghanistan?
Ensure brevity in your answer.  0.08. What is the difference between the highest and the second highest Population growth (in %) of El Salvador?
Offer a very short reply. 0.07. What is the difference between the highest and the second highest Population growth (in %) in Iran?
Your answer should be very brief. 0.12. What is the difference between the highest and the second highest Population growth (in %) of Seychelles?
Keep it short and to the point. 0.65. What is the difference between the highest and the lowest Population growth (in %) in Afghanistan?
Ensure brevity in your answer.  2.1. What is the difference between the highest and the lowest Population growth (in %) in El Salvador?
Keep it short and to the point. 0.29. What is the difference between the highest and the lowest Population growth (in %) of Iran?
Offer a terse response. 0.42. What is the difference between the highest and the lowest Population growth (in %) in Seychelles?
Offer a terse response. 3.38. 